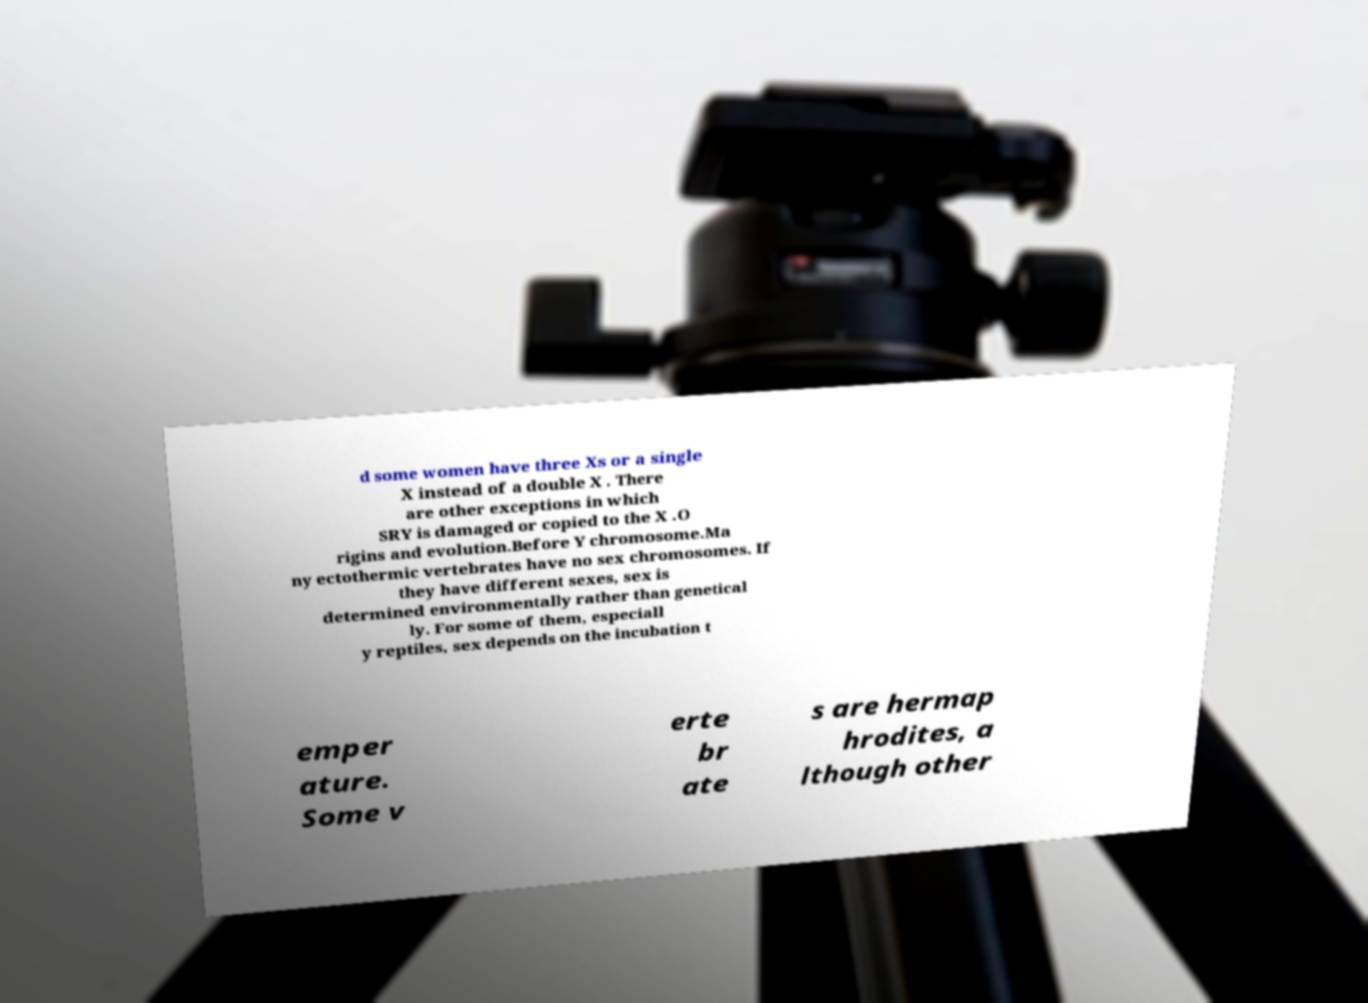Can you read and provide the text displayed in the image?This photo seems to have some interesting text. Can you extract and type it out for me? d some women have three Xs or a single X instead of a double X . There are other exceptions in which SRY is damaged or copied to the X .O rigins and evolution.Before Y chromosome.Ma ny ectothermic vertebrates have no sex chromosomes. If they have different sexes, sex is determined environmentally rather than genetical ly. For some of them, especiall y reptiles, sex depends on the incubation t emper ature. Some v erte br ate s are hermap hrodites, a lthough other 